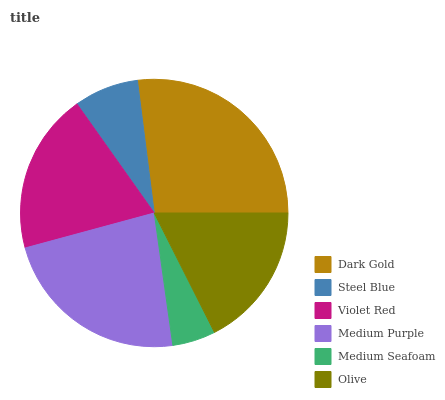Is Medium Seafoam the minimum?
Answer yes or no. Yes. Is Dark Gold the maximum?
Answer yes or no. Yes. Is Steel Blue the minimum?
Answer yes or no. No. Is Steel Blue the maximum?
Answer yes or no. No. Is Dark Gold greater than Steel Blue?
Answer yes or no. Yes. Is Steel Blue less than Dark Gold?
Answer yes or no. Yes. Is Steel Blue greater than Dark Gold?
Answer yes or no. No. Is Dark Gold less than Steel Blue?
Answer yes or no. No. Is Violet Red the high median?
Answer yes or no. Yes. Is Olive the low median?
Answer yes or no. Yes. Is Olive the high median?
Answer yes or no. No. Is Medium Purple the low median?
Answer yes or no. No. 